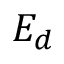<formula> <loc_0><loc_0><loc_500><loc_500>E _ { d }</formula> 